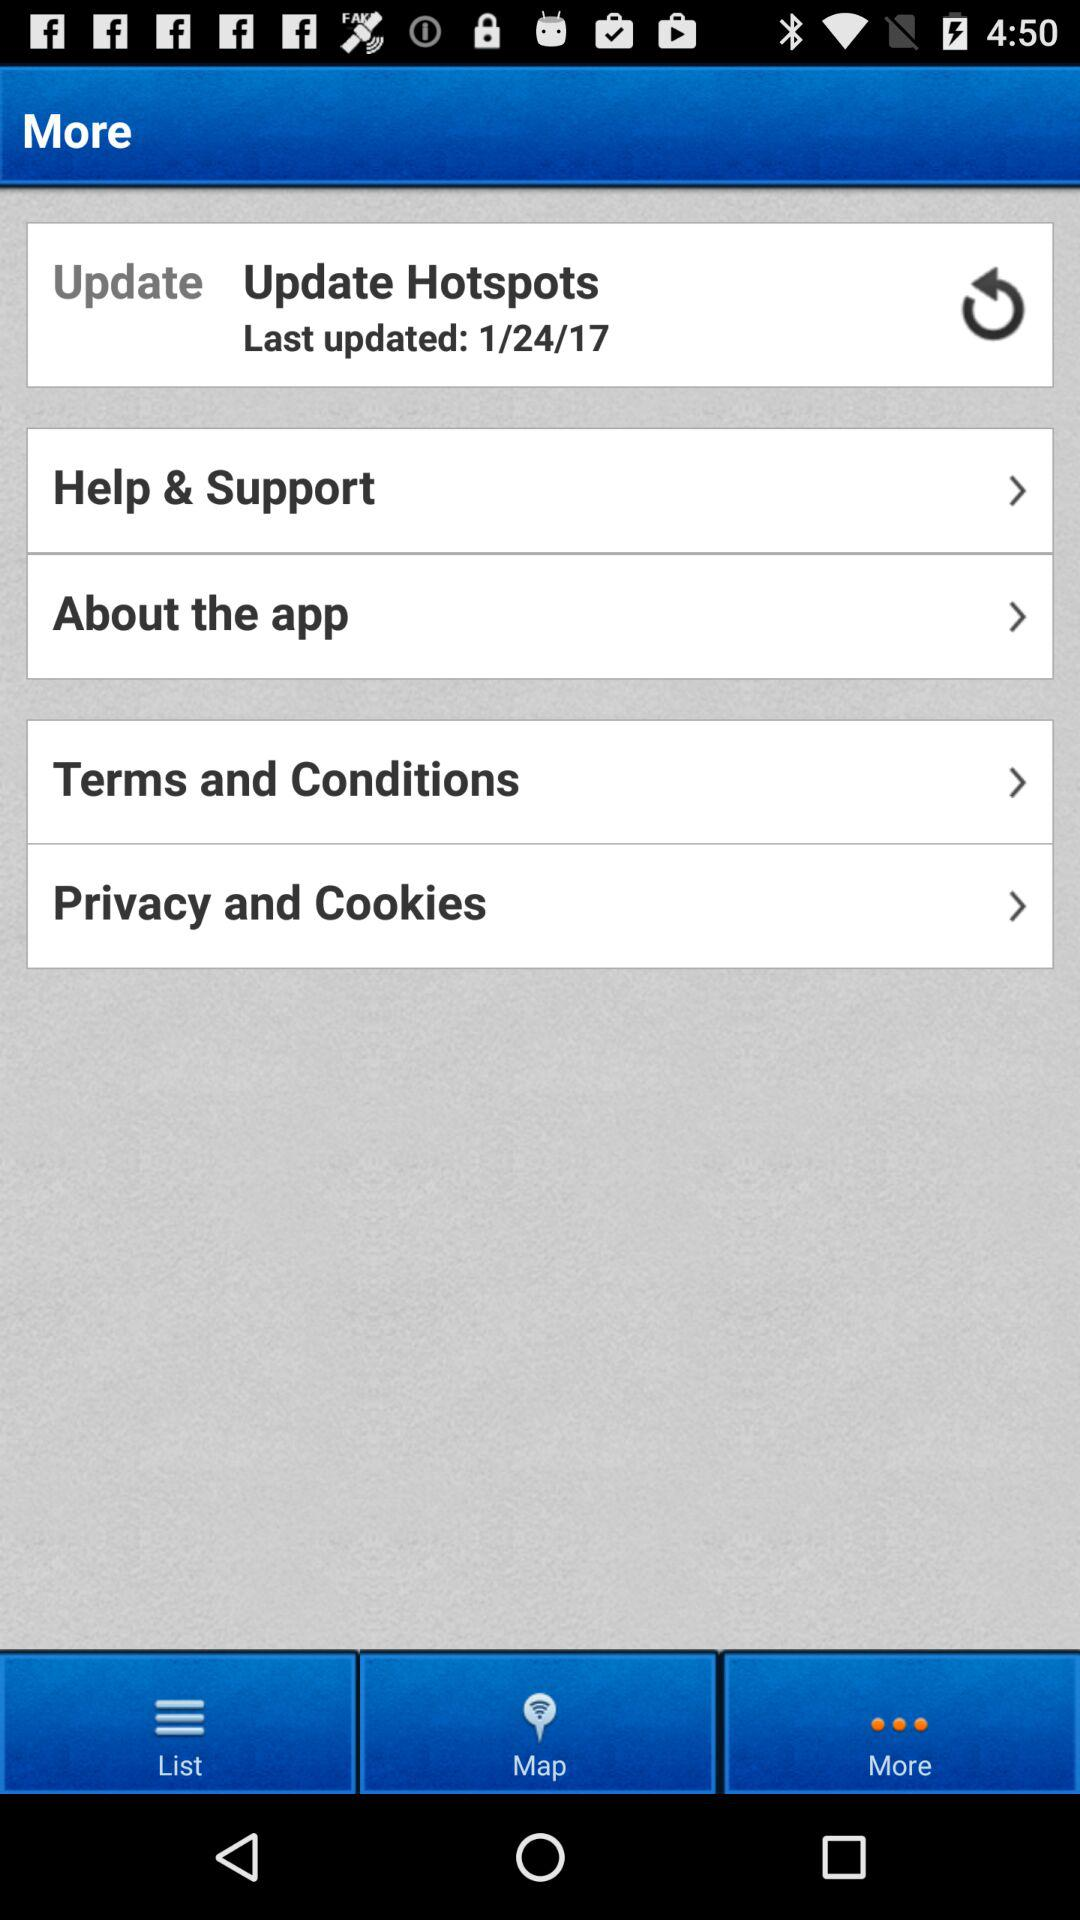When were the hotspots last updated? The hotspots were last updated on January 24, 2017. 